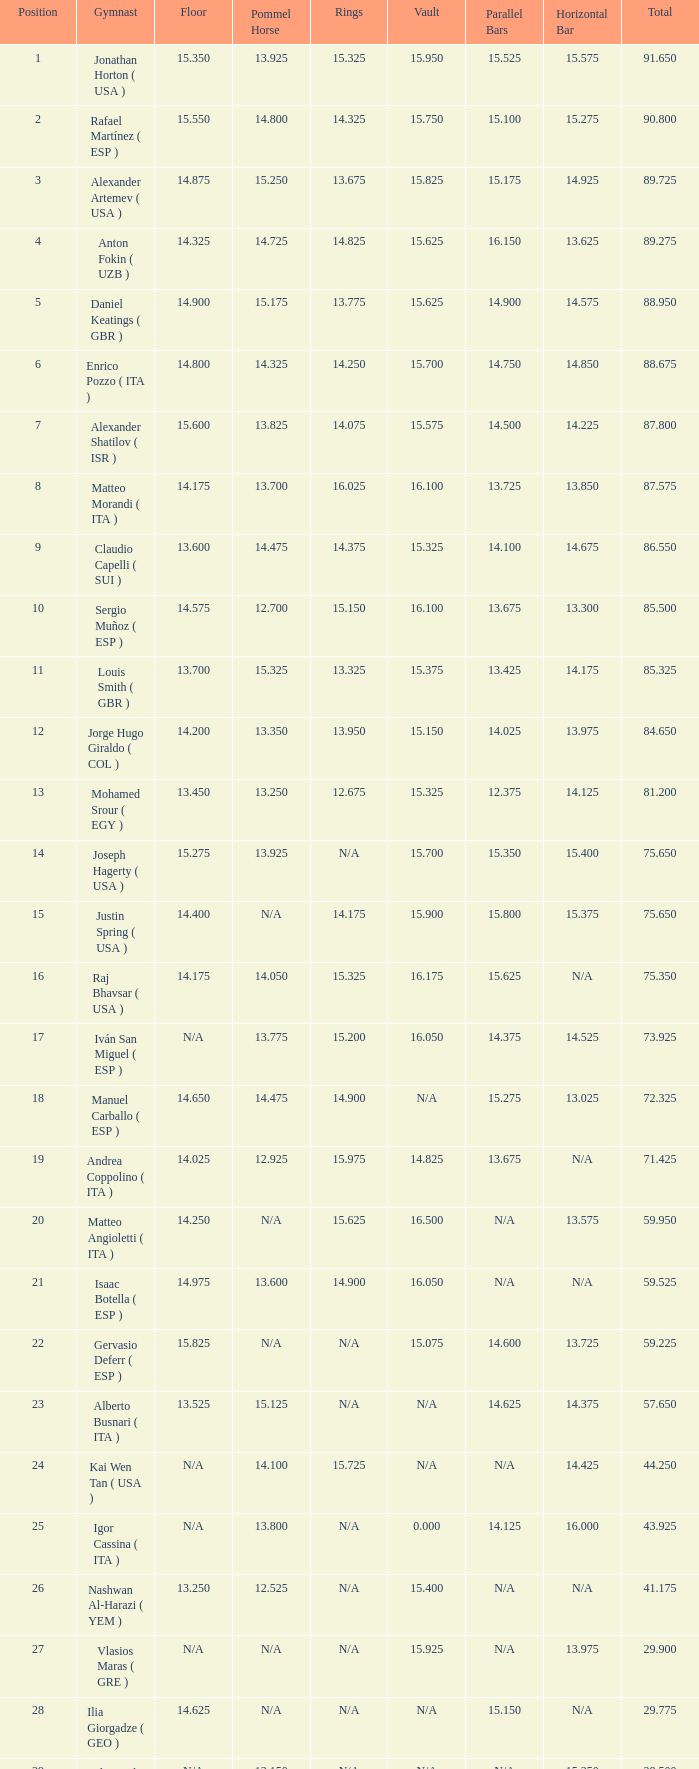Given that the floor's number is 14.200, what is the parallel bars' number? 14.025. 